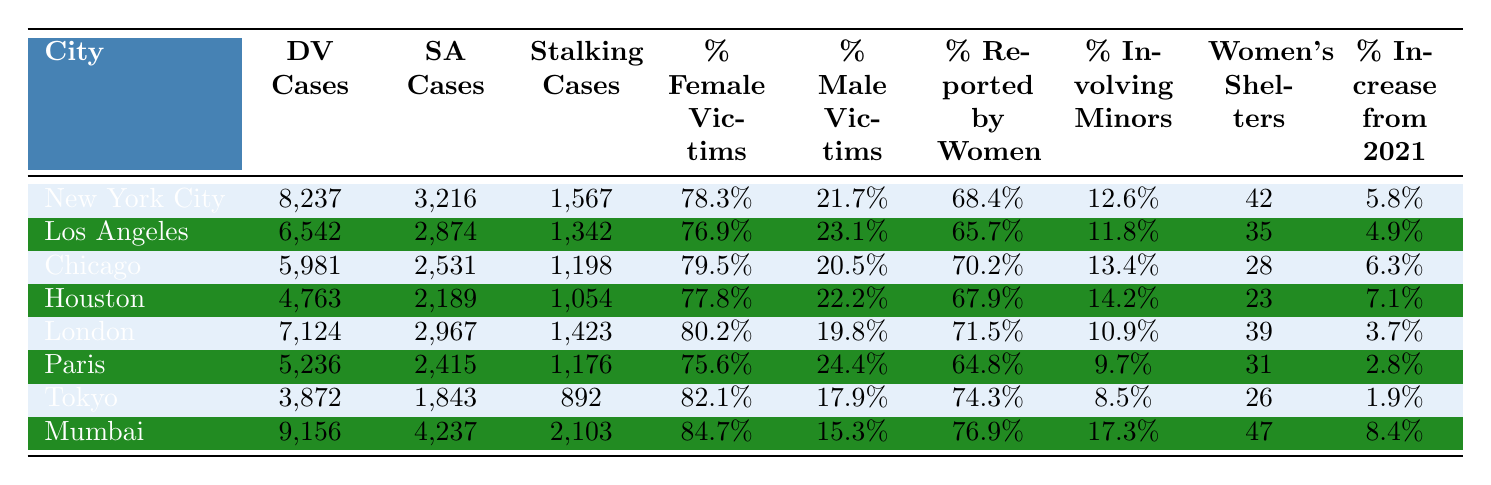What city has the highest reported domestic violence cases in 2022? By examining the 'reported domestic violence cases' column, New York City has the highest value of 8,237 cases in 2022.
Answer: New York City What is the percentage of female victims in Chicago? Looking at the 'percentage female victims' column for Chicago, it shows 79.5%.
Answer: 79.5% How many women's shelters are there in Mumbai? Referring to the 'number of women's shelters' column for Mumbai, there are 47 shelters listed.
Answer: 47 What is the average number of reported sexual assault cases across all cities? First, sum the reported sexual assault cases: (3216 + 2874 + 2531 + 2189 + 2967 + 2415 + 1843 + 4237) = 19762. Then divide by the number of cities (8): 19762 / 8 = 2470.25, which rounds to 2470.
Answer: 2470 Which city has the lowest percentage of cases involving minors? By checking the 'percentage cases involving minors' column, Tokyo has the lowest percentage at 8.5%.
Answer: Tokyo Are there more reported stalking cases in Houston than in Paris? Houston has 1,054 reported stalking cases while Paris has 1,176. Since 1,054 is less than 1,176, the statement is false.
Answer: No What is the percentage increase from 2021 for Los Angeles? The 'percentage increase from 2021' for Los Angeles is 4.9%, directly taken from the table.
Answer: 4.9% How do the reported domestic violence cases in New York City compare to those in Mumbai? New York City's reported domestic violence cases are 8,237, while Mumbai's cases are 9,156. Since 8,237 is less than 9,156, New York City has fewer.
Answer: Fewer In which city is the percentage of cases reported by women the highest? The 'percentage cases reported by women' column indicates that Mumbai has the highest percentage at 76.9%.
Answer: Mumbai What is the total number of reported cases (domestic violence, sexual assault, and stalking) for London? Adding the cases from each relevant column for London: 7,124 (DV) + 2,967 (SA) + 1,423 (stalking) = 11,514 total reported cases.
Answer: 11514 